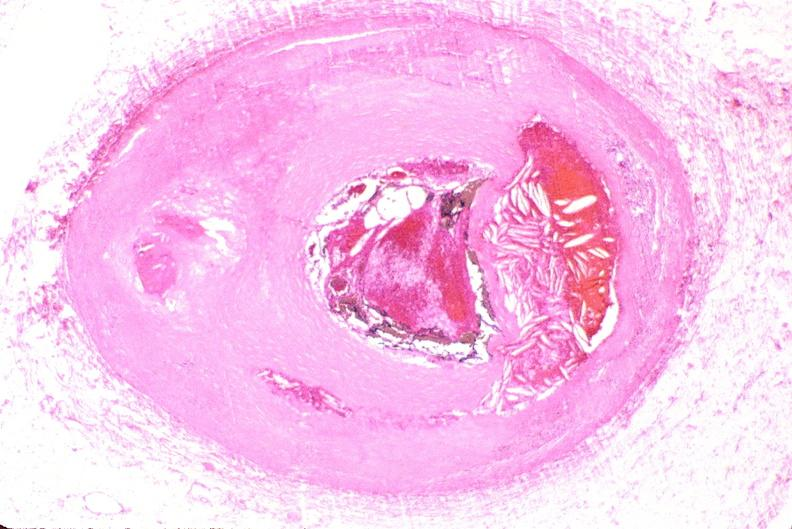what does this image show?
Answer the question using a single word or phrase. Right coronary artery 